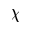<formula> <loc_0><loc_0><loc_500><loc_500>\chi</formula> 